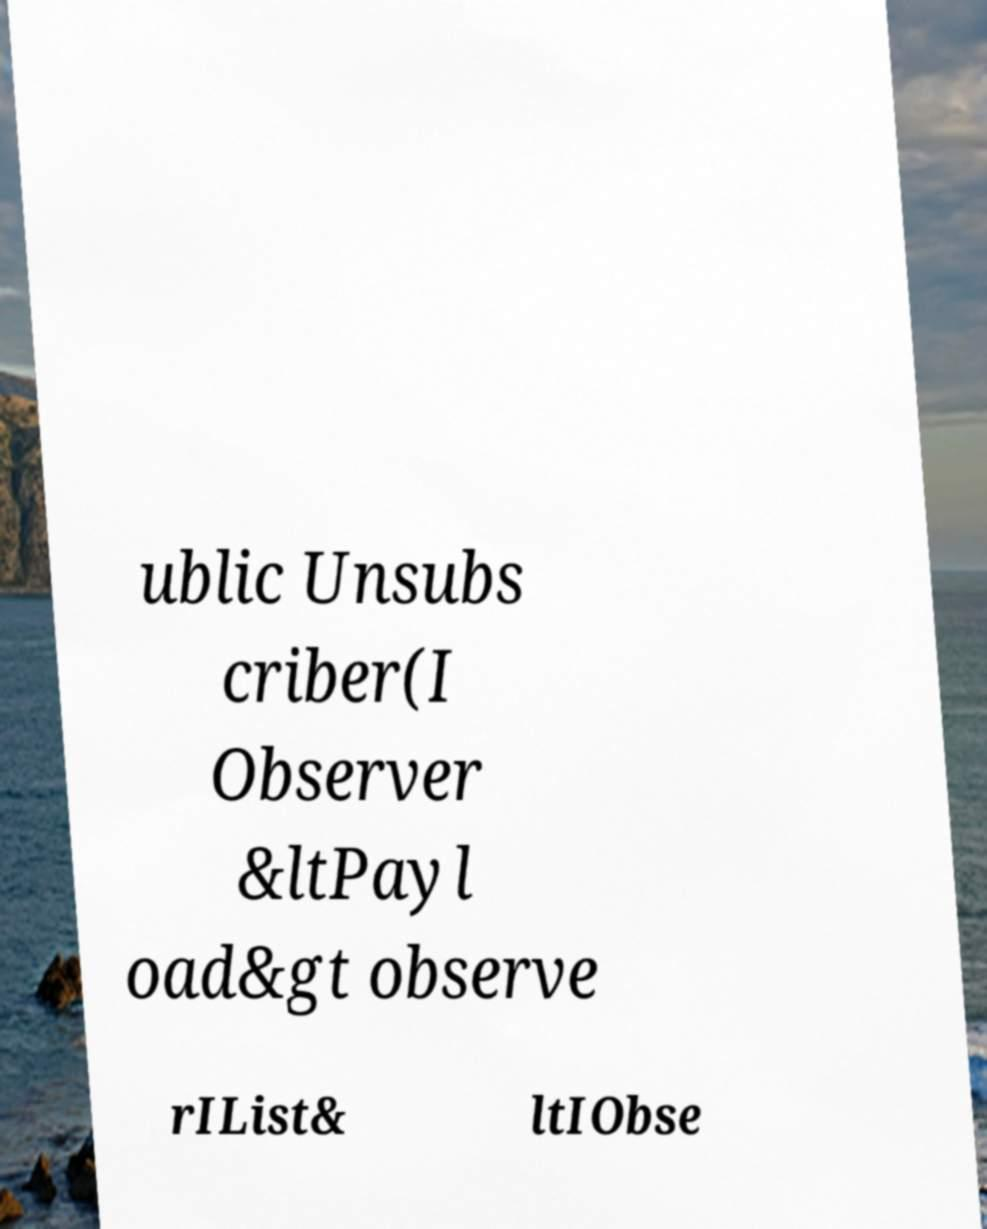Can you read and provide the text displayed in the image?This photo seems to have some interesting text. Can you extract and type it out for me? ublic Unsubs criber(I Observer &ltPayl oad&gt observe rIList& ltIObse 